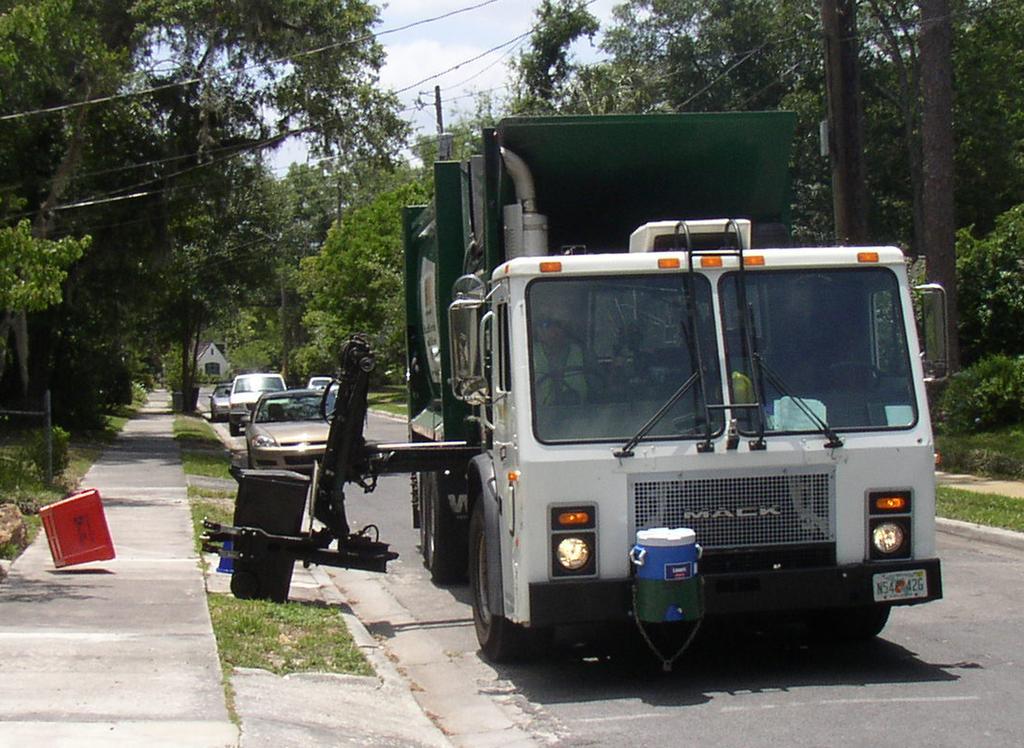In one or two sentences, can you explain what this image depicts? In this image we can see vehicles on the road and there are trees. We can see wires. In the background there is sky. There is a shed. 